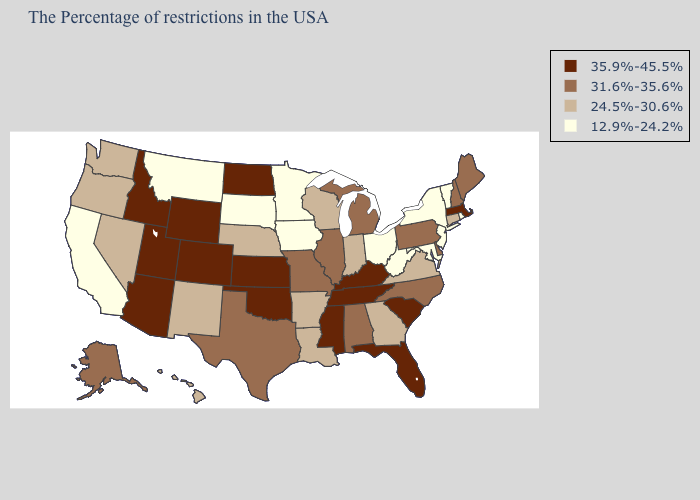What is the lowest value in the USA?
Be succinct. 12.9%-24.2%. What is the lowest value in the West?
Be succinct. 12.9%-24.2%. Is the legend a continuous bar?
Keep it brief. No. Name the states that have a value in the range 24.5%-30.6%?
Short answer required. Connecticut, Virginia, Georgia, Indiana, Wisconsin, Louisiana, Arkansas, Nebraska, New Mexico, Nevada, Washington, Oregon, Hawaii. What is the lowest value in the Northeast?
Give a very brief answer. 12.9%-24.2%. Does the map have missing data?
Short answer required. No. What is the lowest value in the Northeast?
Give a very brief answer. 12.9%-24.2%. What is the lowest value in the West?
Write a very short answer. 12.9%-24.2%. What is the highest value in states that border Missouri?
Concise answer only. 35.9%-45.5%. Does Mississippi have a higher value than Nevada?
Answer briefly. Yes. What is the value of Nevada?
Short answer required. 24.5%-30.6%. Name the states that have a value in the range 12.9%-24.2%?
Concise answer only. Rhode Island, Vermont, New York, New Jersey, Maryland, West Virginia, Ohio, Minnesota, Iowa, South Dakota, Montana, California. What is the value of South Dakota?
Answer briefly. 12.9%-24.2%. What is the value of Texas?
Answer briefly. 31.6%-35.6%. Name the states that have a value in the range 35.9%-45.5%?
Concise answer only. Massachusetts, South Carolina, Florida, Kentucky, Tennessee, Mississippi, Kansas, Oklahoma, North Dakota, Wyoming, Colorado, Utah, Arizona, Idaho. 